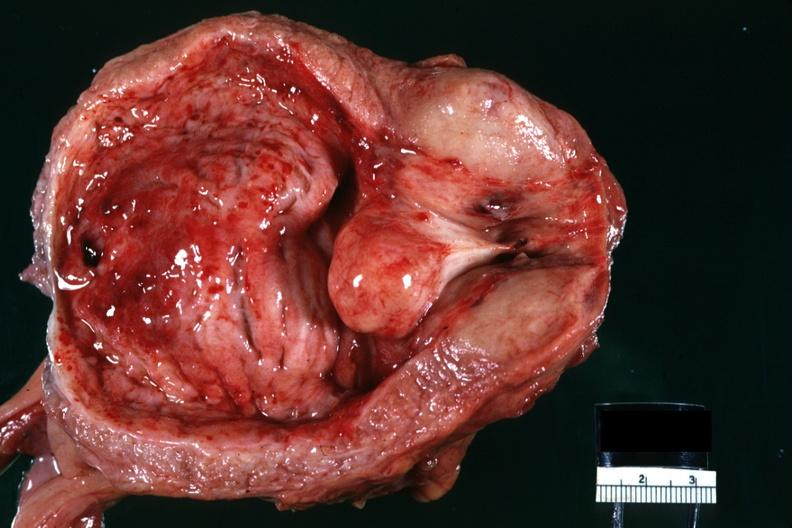what does this image show?
Answer the question using a single word or phrase. Close-up median lobe hyperplasia so-called median bar lesion very good hemorrhagic cystitis 